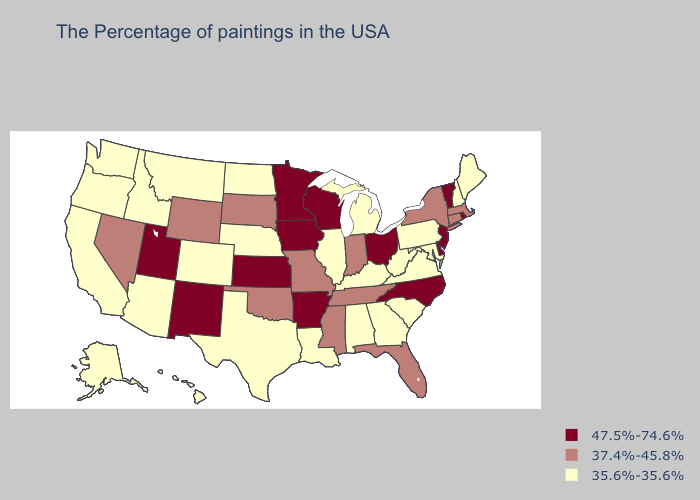Among the states that border Connecticut , does Rhode Island have the lowest value?
Keep it brief. No. Does the first symbol in the legend represent the smallest category?
Answer briefly. No. Name the states that have a value in the range 37.4%-45.8%?
Give a very brief answer. Massachusetts, Connecticut, New York, Florida, Indiana, Tennessee, Mississippi, Missouri, Oklahoma, South Dakota, Wyoming, Nevada. Which states have the lowest value in the West?
Keep it brief. Colorado, Montana, Arizona, Idaho, California, Washington, Oregon, Alaska, Hawaii. Does the map have missing data?
Give a very brief answer. No. What is the highest value in the MidWest ?
Keep it brief. 47.5%-74.6%. What is the value of Wyoming?
Concise answer only. 37.4%-45.8%. Does Nevada have the lowest value in the West?
Quick response, please. No. How many symbols are there in the legend?
Write a very short answer. 3. Among the states that border West Virginia , which have the lowest value?
Concise answer only. Maryland, Pennsylvania, Virginia, Kentucky. What is the value of Michigan?
Short answer required. 35.6%-35.6%. Name the states that have a value in the range 37.4%-45.8%?
Give a very brief answer. Massachusetts, Connecticut, New York, Florida, Indiana, Tennessee, Mississippi, Missouri, Oklahoma, South Dakota, Wyoming, Nevada. Among the states that border Montana , does South Dakota have the lowest value?
Quick response, please. No. What is the lowest value in the South?
Be succinct. 35.6%-35.6%. 